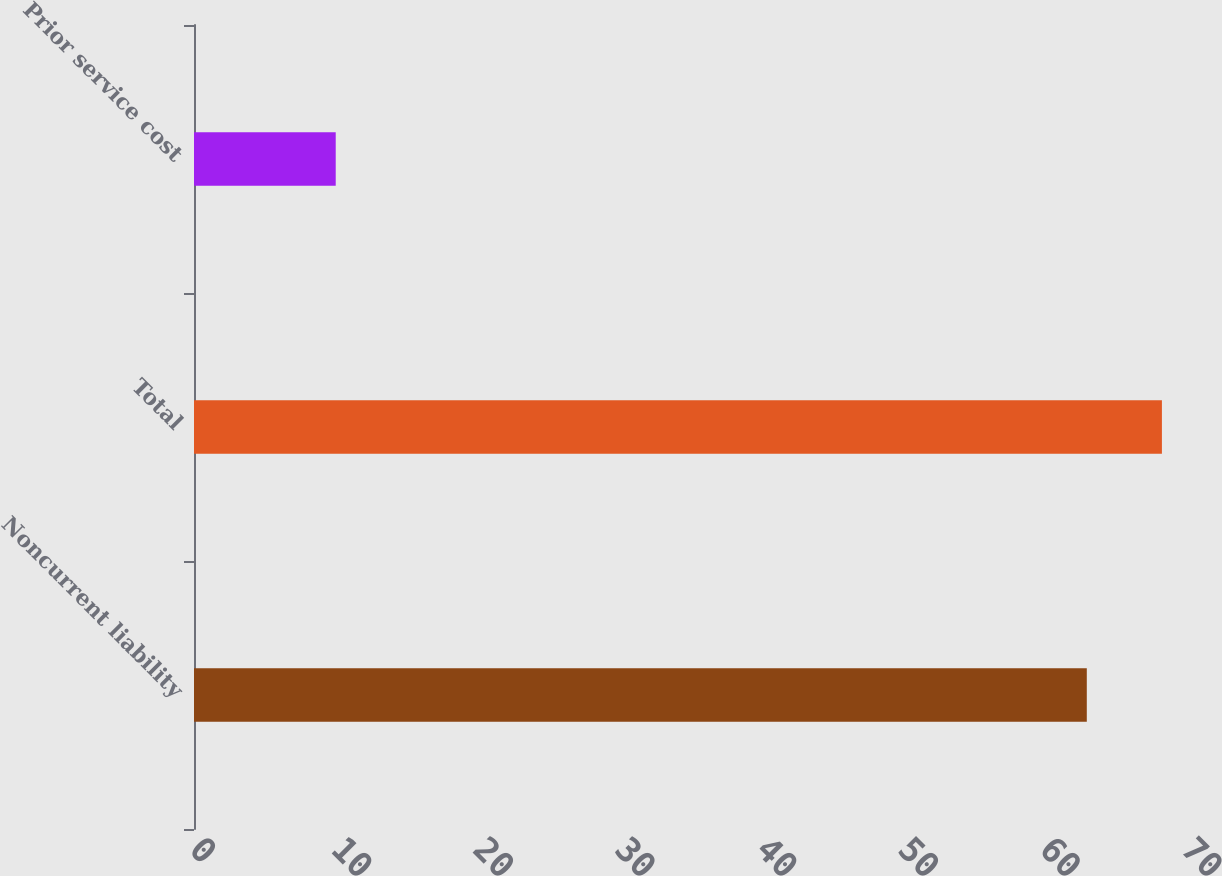<chart> <loc_0><loc_0><loc_500><loc_500><bar_chart><fcel>Noncurrent liability<fcel>Total<fcel>Prior service cost<nl><fcel>63<fcel>68.3<fcel>10<nl></chart> 